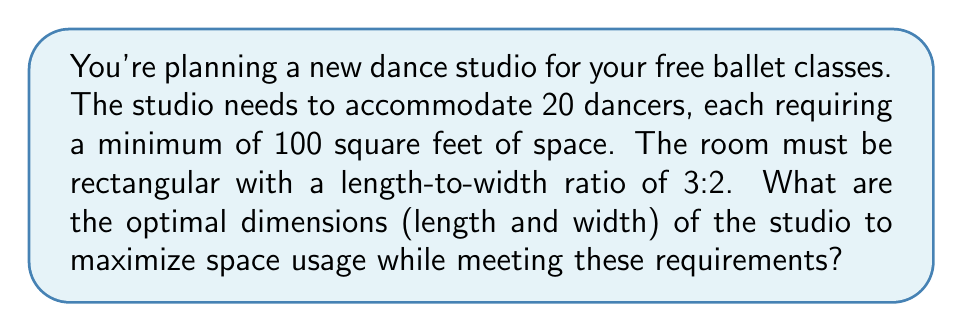Show me your answer to this math problem. Let's approach this step-by-step:

1) First, calculate the minimum total area required:
   $$ \text{Minimum Area} = 20 \text{ dancers} \times 100 \text{ sq ft} = 2000 \text{ sq ft} $$

2) Let the width of the room be $w$ and the length be $l$. Given the 3:2 ratio:
   $$ l = \frac{3}{2}w $$

3) The area of the room is length times width:
   $$ A = l \times w = \frac{3}{2}w \times w = \frac{3}{2}w^2 $$

4) We know this area must be at least 2000 sq ft:
   $$ \frac{3}{2}w^2 \geq 2000 $$

5) Solve for $w$:
   $$ w^2 \geq \frac{2000 \times 2}{3} \approx 1333.33 $$
   $$ w \geq \sqrt{1333.33} \approx 36.51 $$

6) Round up to the nearest foot for practical purposes:
   $$ w = 37 \text{ ft} $$

7) Calculate the length:
   $$ l = \frac{3}{2} \times 37 = 55.5 \text{ ft} $$

8) Round up the length to the nearest foot:
   $$ l = 56 \text{ ft} $$

9) Check the final area:
   $$ A = 37 \text{ ft} \times 56 \text{ ft} = 2072 \text{ sq ft} $$

This exceeds the minimum required area while maintaining the 3:2 ratio.
Answer: Length: 56 ft, Width: 37 ft 